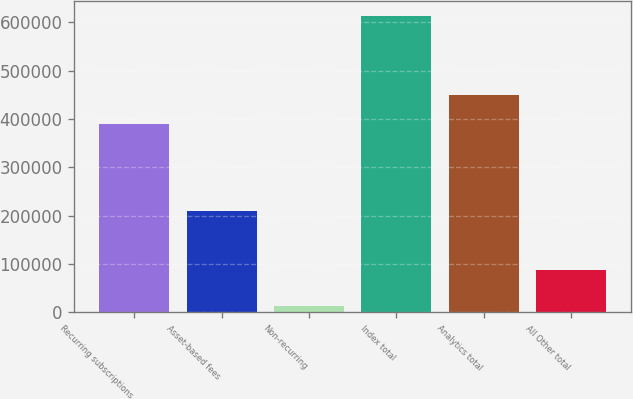<chart> <loc_0><loc_0><loc_500><loc_500><bar_chart><fcel>Recurring subscriptions<fcel>Asset-based fees<fcel>Non-recurring<fcel>Index total<fcel>Analytics total<fcel>All Other total<nl><fcel>389348<fcel>210229<fcel>13974<fcel>613551<fcel>449306<fcel>88765<nl></chart> 